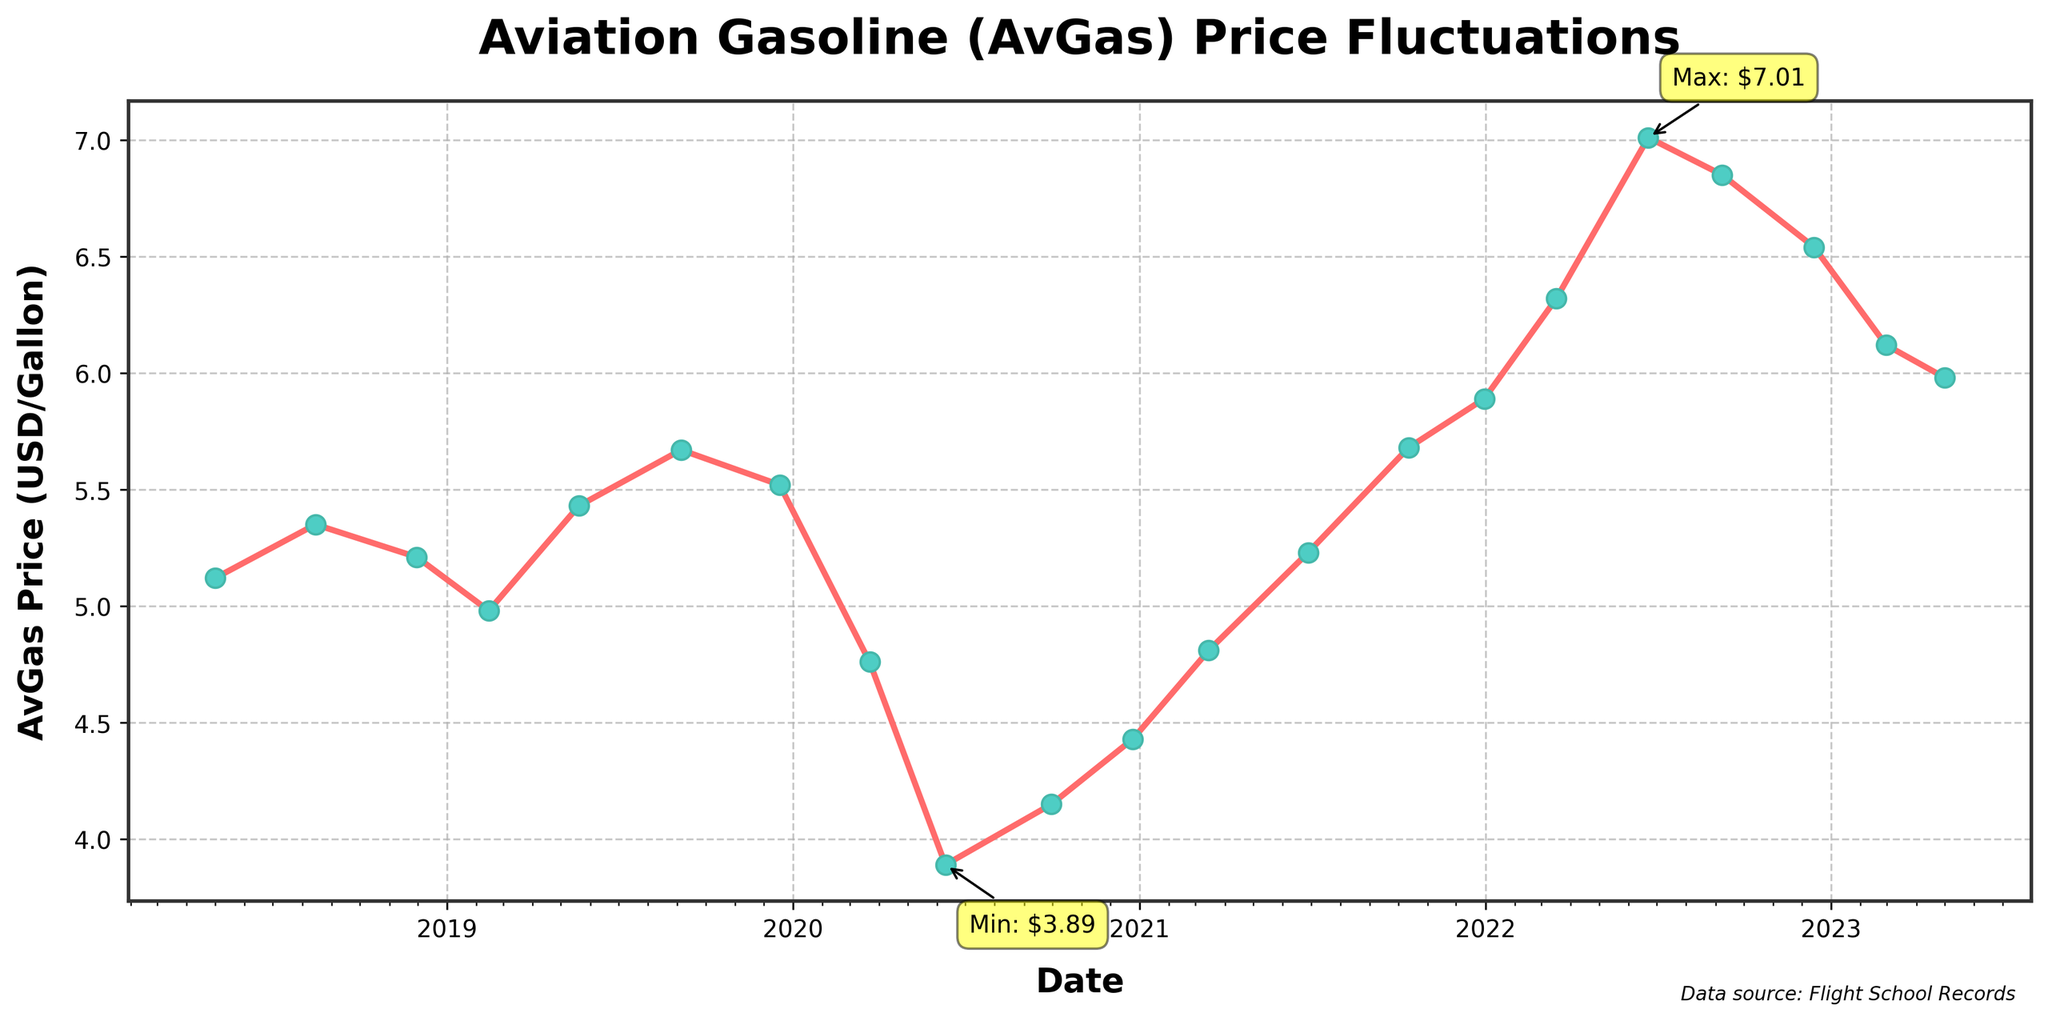How did the AvGas price change between June 2020 and June 2021? To find the change, locate the prices on June 2020 and June 2021 on the plot. The price in June 2020 is approximately $3.89, and in June 2021 it is about $5.23. The change is $5.23 - $3.89.
Answer: $1.34 increase Which month and year had the highest AvGas price? The figure annotated the highest price with a yellow box. By locating this annotation, we see the highest price around June 2022.
Answer: June 2022 Which month and year had the lowest AvGas price? The figure annotated the lowest price with a yellow box. By locating this annotation, we see the lowest price around June 2020.
Answer: June 2020 What was the approximate average AvGas price in the year 2022? Average is calculated by summing the quarterly prices in 2022 and dividing by 4. Based on the data points: (6.32 + 7.01 + 6.85 + 6.54)/4 = 6.68.
Answer: $6.68 Did the AvGas price ever drop back to the same level it was in December 2019? Check the price in December 2019, which is around $5.52. Look for any point where price dips to this value. No such dips occur post December 2019.
Answer: No How did the AvGas price trend during the Covid-19 pandemic in 2020? Between March 2020 and December 2020, locate and observe price fluctuations: Prices drop from $4.76 in March 2020 to $3.89 in June 2020, indicating a decrease. Then it gradually increases back to $4.43 by December 2020.
Answer: Decrease initially, then slight increase Compare the AvGas price on March 2020 and March 2021. Which was higher? Compare prices between March 2020 ($4.76) and March 2021 ($4.81).
Answer: March 2021 is higher How many times did the AvGas price cross $6 per gallon during the period shown? Identify each crossing over $6 level. Prices cross this mark three times in (2022-03, 2022-06, 2022-09 and linger around until 2023).
Answer: Three times Describe the slope of the price curve from early 2021 to mid-2022. Observe the trend line from early 2021 to mid-2022. The line shows a strong upward trend, indicating a steady price increase.
Answer: Upward slope What is the duration of the longest continuous increase in AvGas price? Identify the longest increasing period. From Dec 2020 ($4.43) to June 2022 ($7.01) represents continuous increase (about 1.5 years).
Answer: Approximately 1.5 years 